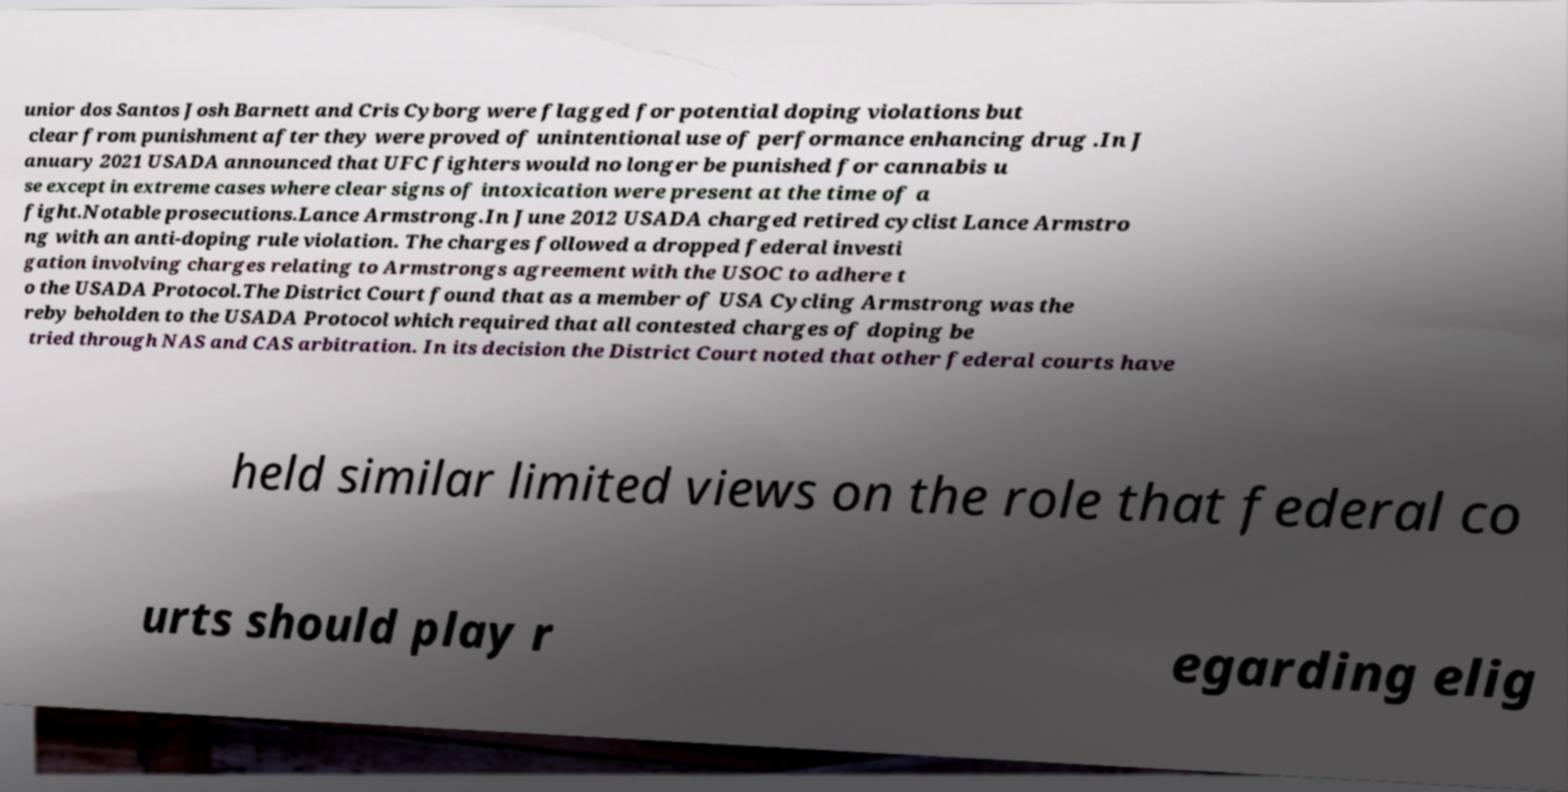Please read and relay the text visible in this image. What does it say? unior dos Santos Josh Barnett and Cris Cyborg were flagged for potential doping violations but clear from punishment after they were proved of unintentional use of performance enhancing drug .In J anuary 2021 USADA announced that UFC fighters would no longer be punished for cannabis u se except in extreme cases where clear signs of intoxication were present at the time of a fight.Notable prosecutions.Lance Armstrong.In June 2012 USADA charged retired cyclist Lance Armstro ng with an anti-doping rule violation. The charges followed a dropped federal investi gation involving charges relating to Armstrongs agreement with the USOC to adhere t o the USADA Protocol.The District Court found that as a member of USA Cycling Armstrong was the reby beholden to the USADA Protocol which required that all contested charges of doping be tried through NAS and CAS arbitration. In its decision the District Court noted that other federal courts have held similar limited views on the role that federal co urts should play r egarding elig 